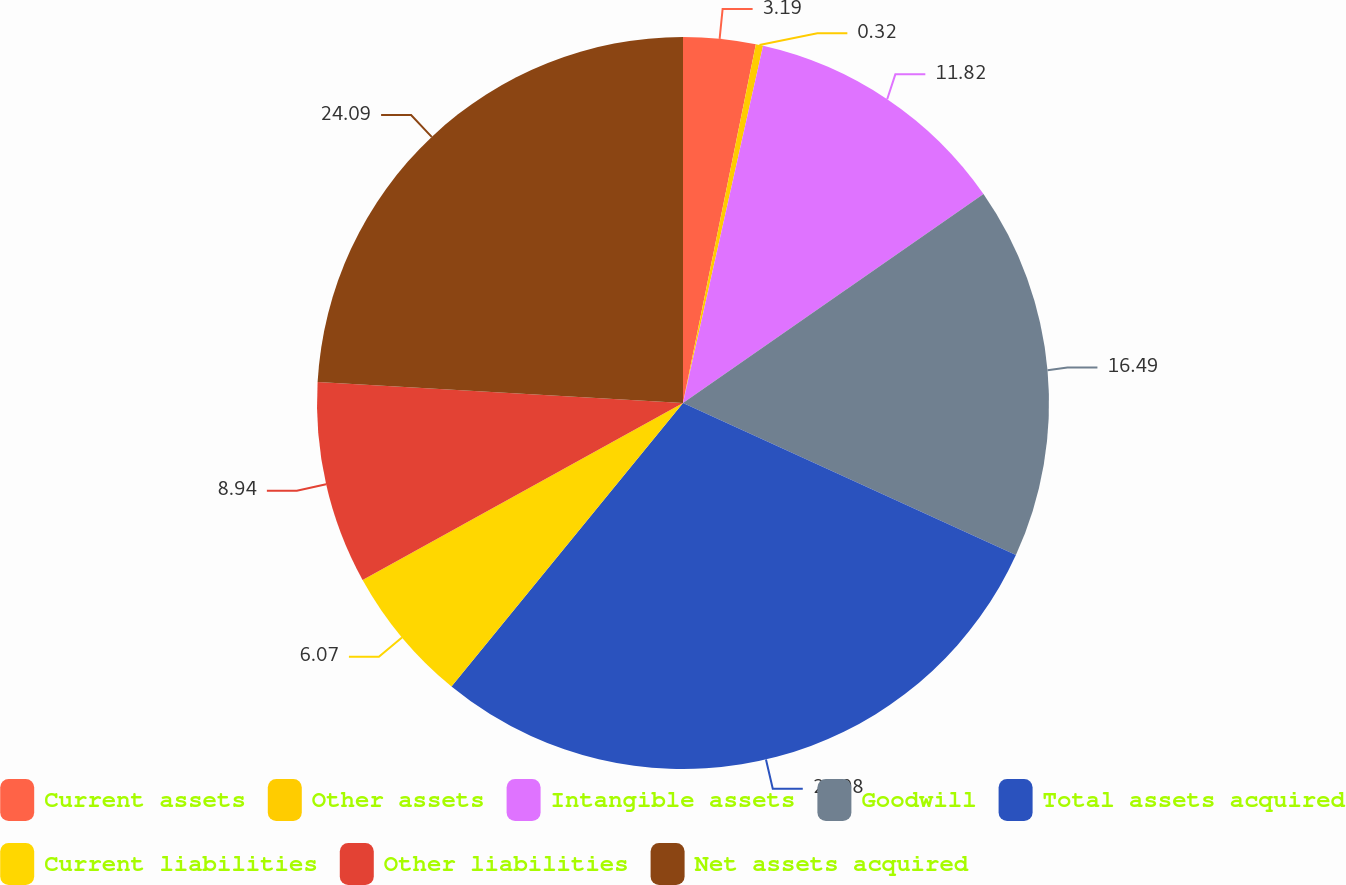<chart> <loc_0><loc_0><loc_500><loc_500><pie_chart><fcel>Current assets<fcel>Other assets<fcel>Intangible assets<fcel>Goodwill<fcel>Total assets acquired<fcel>Current liabilities<fcel>Other liabilities<fcel>Net assets acquired<nl><fcel>3.19%<fcel>0.32%<fcel>11.82%<fcel>16.49%<fcel>29.08%<fcel>6.07%<fcel>8.94%<fcel>24.09%<nl></chart> 